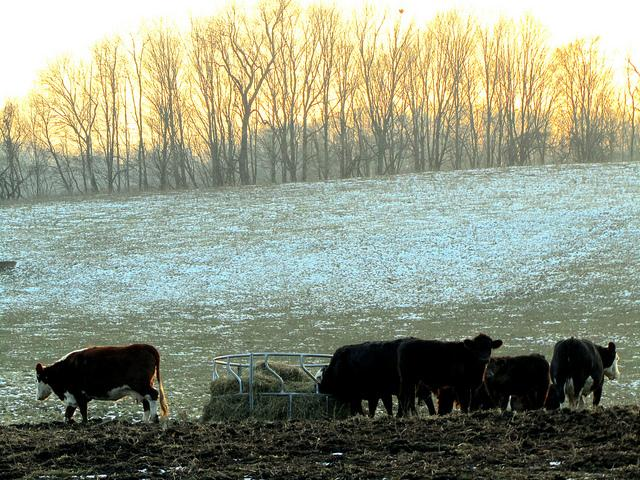What weather event happened recently?

Choices:
A) rain
B) hail
C) flash flood
D) snow snow 